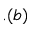Convert formula to latex. <formula><loc_0><loc_0><loc_500><loc_500>. ( b )</formula> 